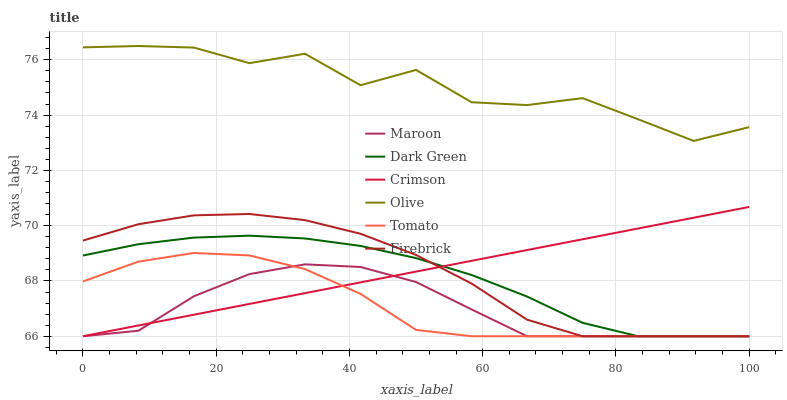Does Maroon have the minimum area under the curve?
Answer yes or no. Yes. Does Olive have the maximum area under the curve?
Answer yes or no. Yes. Does Firebrick have the minimum area under the curve?
Answer yes or no. No. Does Firebrick have the maximum area under the curve?
Answer yes or no. No. Is Crimson the smoothest?
Answer yes or no. Yes. Is Olive the roughest?
Answer yes or no. Yes. Is Firebrick the smoothest?
Answer yes or no. No. Is Firebrick the roughest?
Answer yes or no. No. Does Tomato have the lowest value?
Answer yes or no. Yes. Does Olive have the lowest value?
Answer yes or no. No. Does Olive have the highest value?
Answer yes or no. Yes. Does Firebrick have the highest value?
Answer yes or no. No. Is Dark Green less than Olive?
Answer yes or no. Yes. Is Olive greater than Dark Green?
Answer yes or no. Yes. Does Dark Green intersect Crimson?
Answer yes or no. Yes. Is Dark Green less than Crimson?
Answer yes or no. No. Is Dark Green greater than Crimson?
Answer yes or no. No. Does Dark Green intersect Olive?
Answer yes or no. No. 